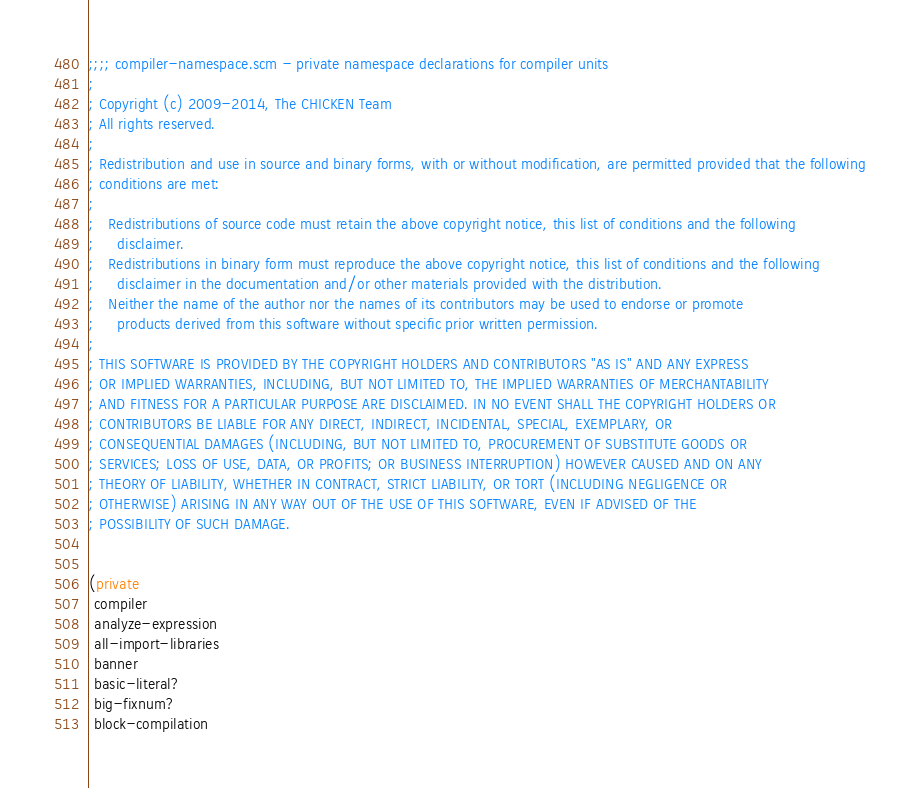<code> <loc_0><loc_0><loc_500><loc_500><_Scheme_>;;;; compiler-namespace.scm - private namespace declarations for compiler units
;
; Copyright (c) 2009-2014, The CHICKEN Team
; All rights reserved.
;
; Redistribution and use in source and binary forms, with or without modification, are permitted provided that the following
; conditions are met:
;
;   Redistributions of source code must retain the above copyright notice, this list of conditions and the following
;     disclaimer. 
;   Redistributions in binary form must reproduce the above copyright notice, this list of conditions and the following
;     disclaimer in the documentation and/or other materials provided with the distribution. 
;   Neither the name of the author nor the names of its contributors may be used to endorse or promote
;     products derived from this software without specific prior written permission. 
;
; THIS SOFTWARE IS PROVIDED BY THE COPYRIGHT HOLDERS AND CONTRIBUTORS "AS IS" AND ANY EXPRESS
; OR IMPLIED WARRANTIES, INCLUDING, BUT NOT LIMITED TO, THE IMPLIED WARRANTIES OF MERCHANTABILITY
; AND FITNESS FOR A PARTICULAR PURPOSE ARE DISCLAIMED. IN NO EVENT SHALL THE COPYRIGHT HOLDERS OR
; CONTRIBUTORS BE LIABLE FOR ANY DIRECT, INDIRECT, INCIDENTAL, SPECIAL, EXEMPLARY, OR
; CONSEQUENTIAL DAMAGES (INCLUDING, BUT NOT LIMITED TO, PROCUREMENT OF SUBSTITUTE GOODS OR
; SERVICES; LOSS OF USE, DATA, OR PROFITS; OR BUSINESS INTERRUPTION) HOWEVER CAUSED AND ON ANY
; THEORY OF LIABILITY, WHETHER IN CONTRACT, STRICT LIABILITY, OR TORT (INCLUDING NEGLIGENCE OR
; OTHERWISE) ARISING IN ANY WAY OUT OF THE USE OF THIS SOFTWARE, EVEN IF ADVISED OF THE
; POSSIBILITY OF SUCH DAMAGE.


(private
 compiler
 analyze-expression
 all-import-libraries
 banner
 basic-literal?
 big-fixnum?
 block-compilation</code> 